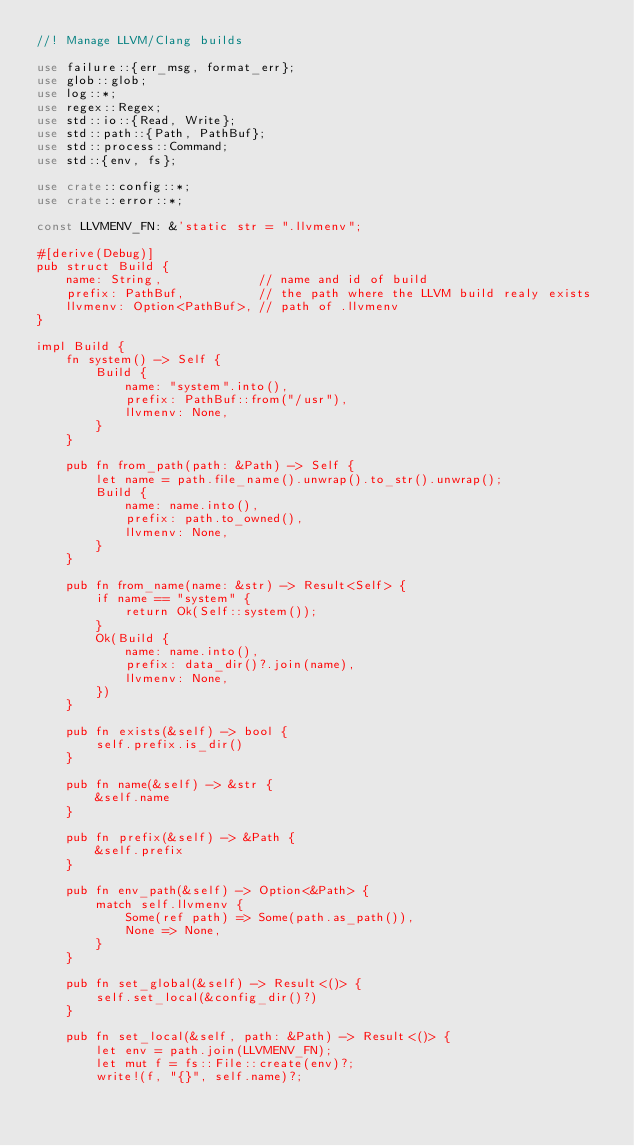Convert code to text. <code><loc_0><loc_0><loc_500><loc_500><_Rust_>//! Manage LLVM/Clang builds

use failure::{err_msg, format_err};
use glob::glob;
use log::*;
use regex::Regex;
use std::io::{Read, Write};
use std::path::{Path, PathBuf};
use std::process::Command;
use std::{env, fs};

use crate::config::*;
use crate::error::*;

const LLVMENV_FN: &'static str = ".llvmenv";

#[derive(Debug)]
pub struct Build {
    name: String,             // name and id of build
    prefix: PathBuf,          // the path where the LLVM build realy exists
    llvmenv: Option<PathBuf>, // path of .llvmenv
}

impl Build {
    fn system() -> Self {
        Build {
            name: "system".into(),
            prefix: PathBuf::from("/usr"),
            llvmenv: None,
        }
    }

    pub fn from_path(path: &Path) -> Self {
        let name = path.file_name().unwrap().to_str().unwrap();
        Build {
            name: name.into(),
            prefix: path.to_owned(),
            llvmenv: None,
        }
    }

    pub fn from_name(name: &str) -> Result<Self> {
        if name == "system" {
            return Ok(Self::system());
        }
        Ok(Build {
            name: name.into(),
            prefix: data_dir()?.join(name),
            llvmenv: None,
        })
    }

    pub fn exists(&self) -> bool {
        self.prefix.is_dir()
    }

    pub fn name(&self) -> &str {
        &self.name
    }

    pub fn prefix(&self) -> &Path {
        &self.prefix
    }

    pub fn env_path(&self) -> Option<&Path> {
        match self.llvmenv {
            Some(ref path) => Some(path.as_path()),
            None => None,
        }
    }

    pub fn set_global(&self) -> Result<()> {
        self.set_local(&config_dir()?)
    }

    pub fn set_local(&self, path: &Path) -> Result<()> {
        let env = path.join(LLVMENV_FN);
        let mut f = fs::File::create(env)?;
        write!(f, "{}", self.name)?;</code> 